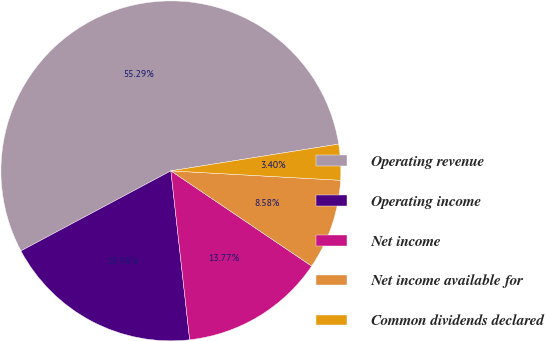Convert chart. <chart><loc_0><loc_0><loc_500><loc_500><pie_chart><fcel>Operating revenue<fcel>Operating income<fcel>Net income<fcel>Net income available for<fcel>Common dividends declared<nl><fcel>55.28%<fcel>18.96%<fcel>13.77%<fcel>8.58%<fcel>3.4%<nl></chart> 